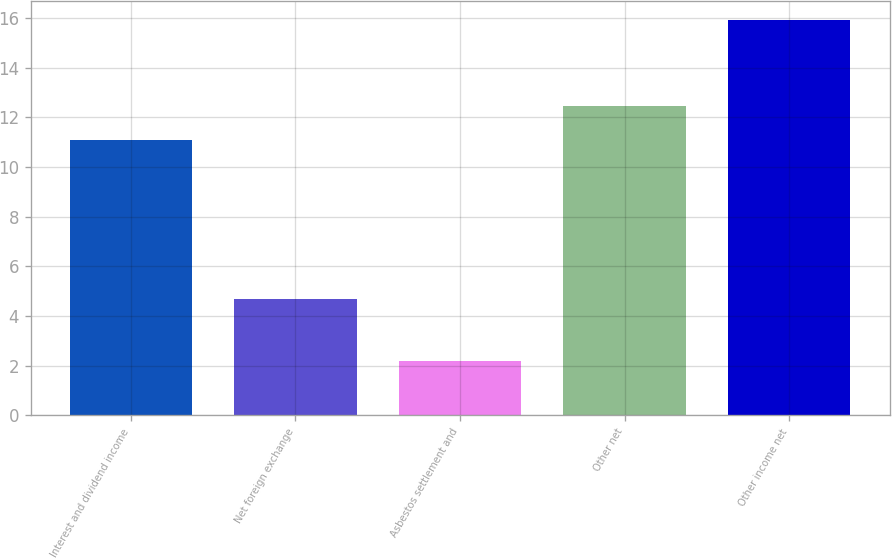Convert chart to OTSL. <chart><loc_0><loc_0><loc_500><loc_500><bar_chart><fcel>Interest and dividend income<fcel>Net foreign exchange<fcel>Asbestos settlement and<fcel>Other net<fcel>Other income net<nl><fcel>11.1<fcel>4.7<fcel>2.2<fcel>12.47<fcel>15.9<nl></chart> 